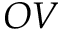<formula> <loc_0><loc_0><loc_500><loc_500>O V</formula> 